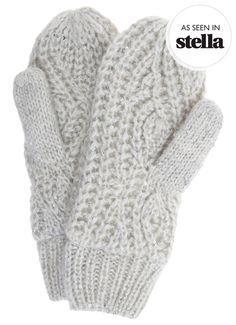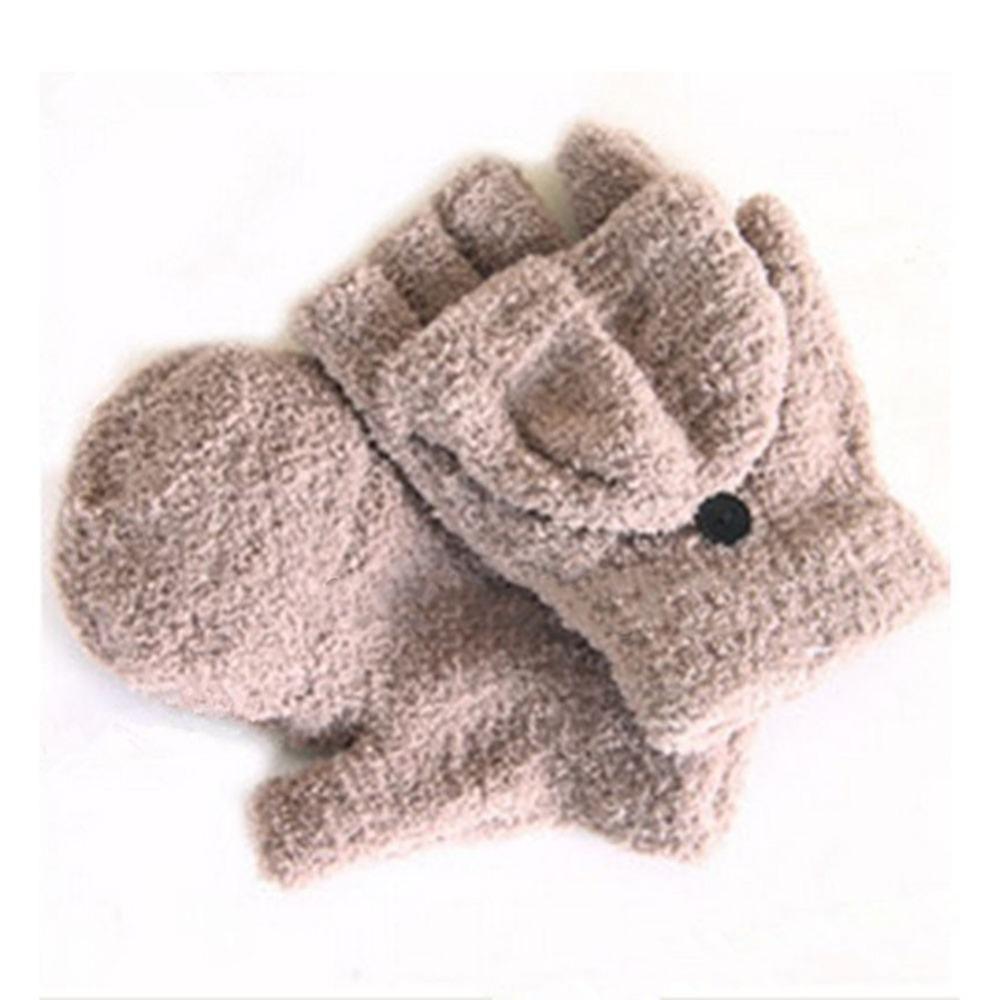The first image is the image on the left, the second image is the image on the right. Considering the images on both sides, is "The image contains fingerless mittens/gloves." valid? Answer yes or no. Yes. The first image is the image on the left, the second image is the image on the right. Examine the images to the left and right. Is the description "There is at least one pair of convertible fingerless gloves." accurate? Answer yes or no. Yes. 